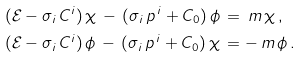<formula> <loc_0><loc_0><loc_500><loc_500>( \mathcal { E } - \sigma _ { i } \, C ^ { i } ) \, \chi \, - \, ( \sigma _ { i } \, p ^ { \, i } + C _ { 0 } ) \, \phi \, & = \, m \, \chi \, , \\ ( \mathcal { E } - \sigma _ { i } \, C ^ { i } ) \, \phi \, - \, ( \sigma _ { i } \, p ^ { \, i } + C _ { 0 } ) \, \chi \, & = - \, m \, \phi \, .</formula> 